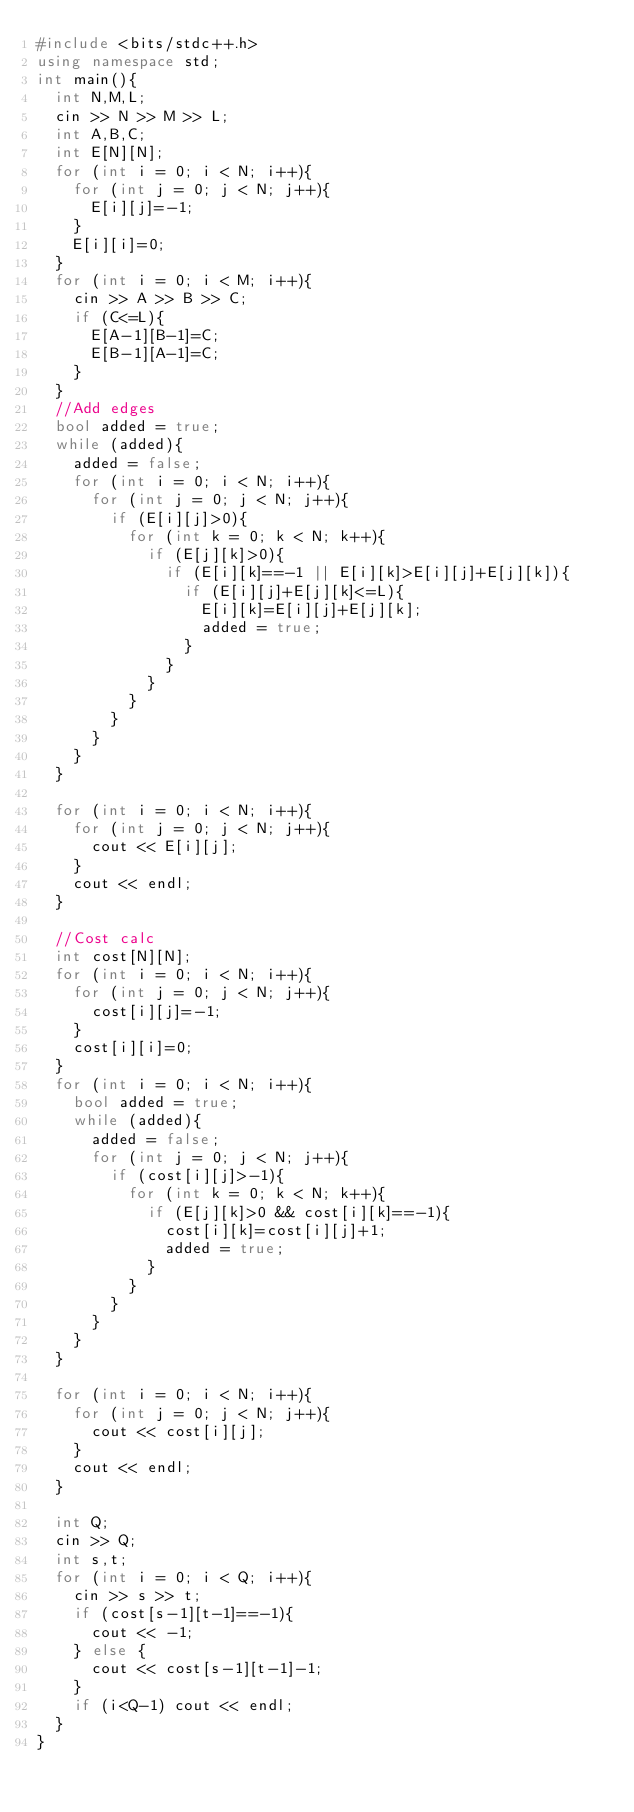Convert code to text. <code><loc_0><loc_0><loc_500><loc_500><_C++_>#include <bits/stdc++.h>
using namespace std;
int main(){
  int N,M,L;
  cin >> N >> M >> L;
  int A,B,C;
  int E[N][N];
  for (int i = 0; i < N; i++){
    for (int j = 0; j < N; j++){
      E[i][j]=-1;
    }
    E[i][i]=0;
  }
  for (int i = 0; i < M; i++){
    cin >> A >> B >> C;
    if (C<=L){
      E[A-1][B-1]=C;
      E[B-1][A-1]=C;
    }
  }
  //Add edges
  bool added = true;
  while (added){
    added = false;
    for (int i = 0; i < N; i++){
      for (int j = 0; j < N; j++){
        if (E[i][j]>0){
          for (int k = 0; k < N; k++){
            if (E[j][k]>0){
              if (E[i][k]==-1 || E[i][k]>E[i][j]+E[j][k]){
                if (E[i][j]+E[j][k]<=L){
                  E[i][k]=E[i][j]+E[j][k];
                  added = true;
                }
              }
            }
          }
        }
      }
    }
  }

  for (int i = 0; i < N; i++){
    for (int j = 0; j < N; j++){
      cout << E[i][j];
    }
    cout << endl;
  }
  
  //Cost calc
  int cost[N][N];
  for (int i = 0; i < N; i++){
    for (int j = 0; j < N; j++){
      cost[i][j]=-1;
    }
    cost[i][i]=0;
  }
  for (int i = 0; i < N; i++){
    bool added = true;
    while (added){
      added = false;
      for (int j = 0; j < N; j++){
        if (cost[i][j]>-1){
          for (int k = 0; k < N; k++){
            if (E[j][k]>0 && cost[i][k]==-1){
              cost[i][k]=cost[i][j]+1;
              added = true;
            }
          }
        }
      }
    }
  }

  for (int i = 0; i < N; i++){
    for (int j = 0; j < N; j++){
      cout << cost[i][j];
    }
    cout << endl;
  }

  int Q;
  cin >> Q;
  int s,t;
  for (int i = 0; i < Q; i++){
    cin >> s >> t;
    if (cost[s-1][t-1]==-1){
      cout << -1;
    } else {
      cout << cost[s-1][t-1]-1;
    }
    if (i<Q-1) cout << endl;
  }
}</code> 